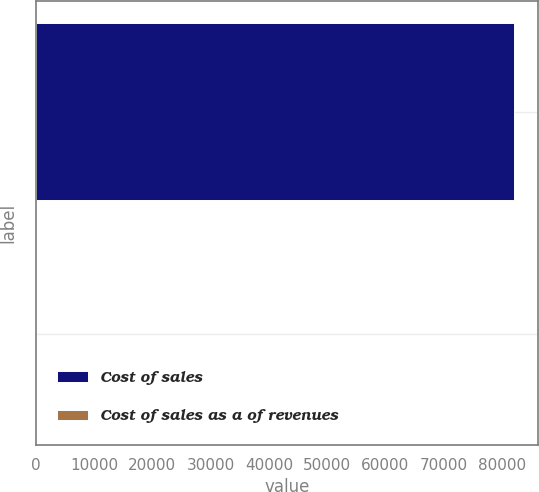<chart> <loc_0><loc_0><loc_500><loc_500><bar_chart><fcel>Cost of sales<fcel>Cost of sales as a of revenues<nl><fcel>82088<fcel>85.4<nl></chart> 